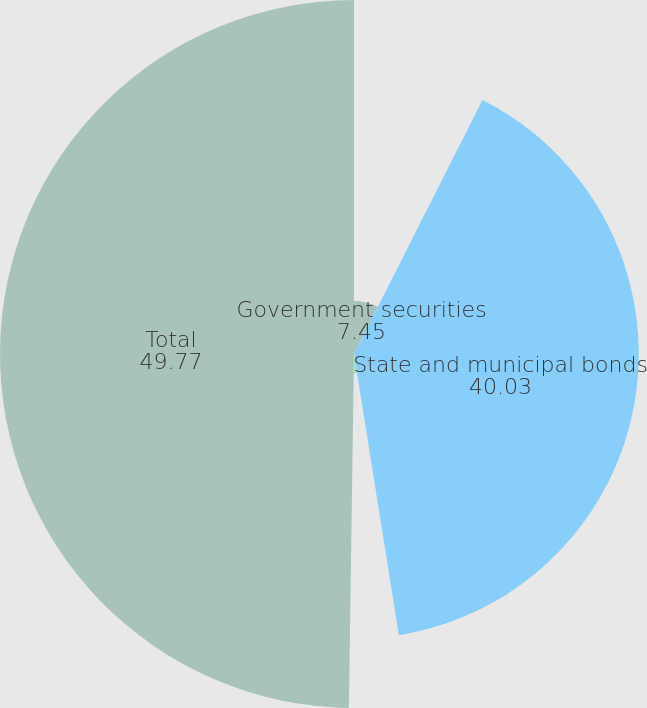<chart> <loc_0><loc_0><loc_500><loc_500><pie_chart><fcel>Government securities<fcel>State and municipal bonds<fcel>Corporate bonds<fcel>Total<nl><fcel>7.45%<fcel>40.03%<fcel>2.75%<fcel>49.77%<nl></chart> 